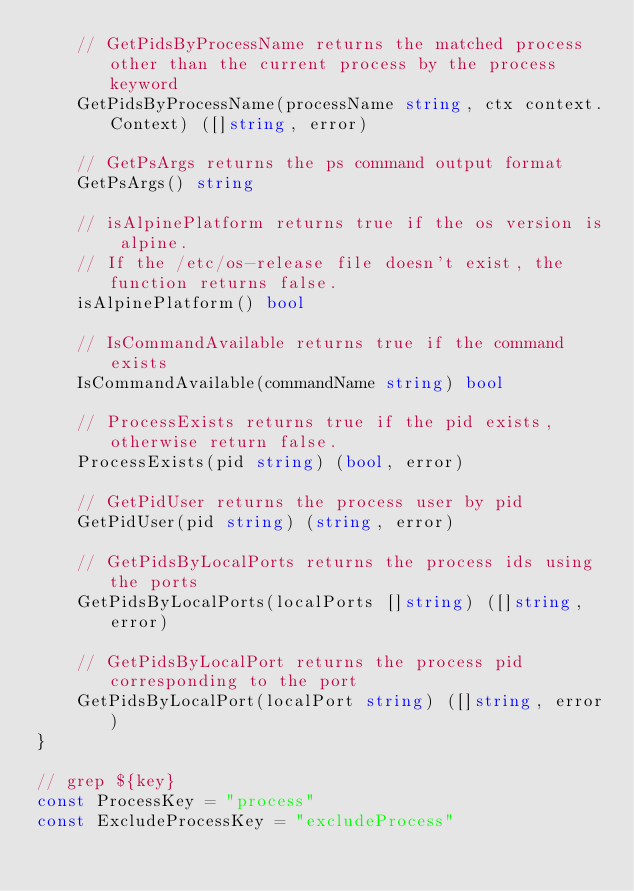Convert code to text. <code><loc_0><loc_0><loc_500><loc_500><_Go_>	// GetPidsByProcessName returns the matched process other than the current process by the process keyword
	GetPidsByProcessName(processName string, ctx context.Context) ([]string, error)

	// GetPsArgs returns the ps command output format
	GetPsArgs() string

	// isAlpinePlatform returns true if the os version is alpine.
	// If the /etc/os-release file doesn't exist, the function returns false.
	isAlpinePlatform() bool

	// IsCommandAvailable returns true if the command exists
	IsCommandAvailable(commandName string) bool

	// ProcessExists returns true if the pid exists, otherwise return false.
	ProcessExists(pid string) (bool, error)

	// GetPidUser returns the process user by pid
	GetPidUser(pid string) (string, error)

	// GetPidsByLocalPorts returns the process ids using the ports
	GetPidsByLocalPorts(localPorts []string) ([]string, error)

	// GetPidsByLocalPort returns the process pid corresponding to the port
	GetPidsByLocalPort(localPort string) ([]string, error)
}

// grep ${key}
const ProcessKey = "process"
const ExcludeProcessKey = "excludeProcess"
</code> 